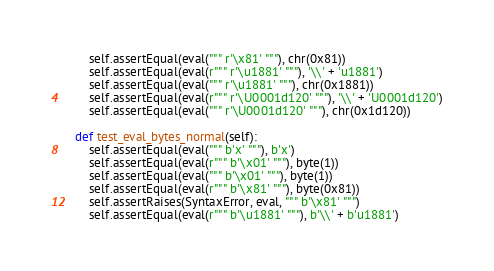Convert code to text. <code><loc_0><loc_0><loc_500><loc_500><_Python_>        self.assertEqual(eval(""" r'\x81' """), chr(0x81))
        self.assertEqual(eval(r""" r'\u1881' """), '\\' + 'u1881')
        self.assertEqual(eval(""" r'\u1881' """), chr(0x1881))
        self.assertEqual(eval(r""" r'\U0001d120' """), '\\' + 'U0001d120')
        self.assertEqual(eval(""" r'\U0001d120' """), chr(0x1d120))

    def test_eval_bytes_normal(self):
        self.assertEqual(eval(""" b'x' """), b'x')
        self.assertEqual(eval(r""" b'\x01' """), byte(1))
        self.assertEqual(eval(""" b'\x01' """), byte(1))
        self.assertEqual(eval(r""" b'\x81' """), byte(0x81))
        self.assertRaises(SyntaxError, eval, """ b'\x81' """)
        self.assertEqual(eval(r""" b'\u1881' """), b'\\' + b'u1881')</code> 